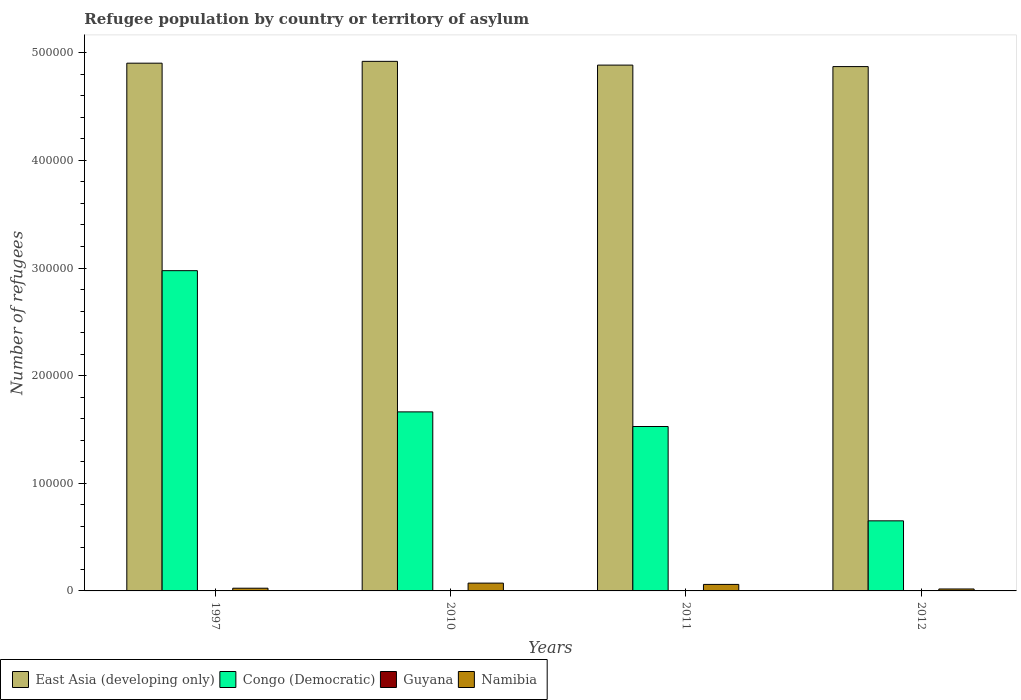How many groups of bars are there?
Offer a very short reply. 4. Are the number of bars per tick equal to the number of legend labels?
Your answer should be compact. Yes. Are the number of bars on each tick of the X-axis equal?
Offer a very short reply. Yes. What is the number of refugees in East Asia (developing only) in 2012?
Keep it short and to the point. 4.87e+05. Across all years, what is the minimum number of refugees in Congo (Democratic)?
Give a very brief answer. 6.51e+04. In which year was the number of refugees in Congo (Democratic) minimum?
Your answer should be very brief. 2012. What is the total number of refugees in Namibia in the graph?
Give a very brief answer. 1.76e+04. What is the difference between the number of refugees in East Asia (developing only) in 1997 and that in 2010?
Provide a succinct answer. -1701. What is the difference between the number of refugees in Guyana in 2010 and the number of refugees in East Asia (developing only) in 2012?
Give a very brief answer. -4.87e+05. What is the average number of refugees in Namibia per year?
Your answer should be compact. 4405. In the year 2011, what is the difference between the number of refugees in Guyana and number of refugees in Namibia?
Keep it short and to the point. -6042. In how many years, is the number of refugees in East Asia (developing only) greater than 120000?
Your response must be concise. 4. What is the ratio of the number of refugees in Namibia in 1997 to that in 2012?
Ensure brevity in your answer.  1.39. Is the number of refugees in Congo (Democratic) in 2011 less than that in 2012?
Your answer should be very brief. No. Is the difference between the number of refugees in Guyana in 1997 and 2012 greater than the difference between the number of refugees in Namibia in 1997 and 2012?
Make the answer very short. No. What is the difference between the highest and the second highest number of refugees in East Asia (developing only)?
Keep it short and to the point. 1701. In how many years, is the number of refugees in East Asia (developing only) greater than the average number of refugees in East Asia (developing only) taken over all years?
Provide a succinct answer. 2. Is the sum of the number of refugees in Guyana in 2010 and 2011 greater than the maximum number of refugees in East Asia (developing only) across all years?
Keep it short and to the point. No. Is it the case that in every year, the sum of the number of refugees in East Asia (developing only) and number of refugees in Congo (Democratic) is greater than the sum of number of refugees in Namibia and number of refugees in Guyana?
Your answer should be very brief. Yes. What does the 4th bar from the left in 2012 represents?
Provide a succinct answer. Namibia. What does the 3rd bar from the right in 2012 represents?
Your response must be concise. Congo (Democratic). Is it the case that in every year, the sum of the number of refugees in Congo (Democratic) and number of refugees in Namibia is greater than the number of refugees in Guyana?
Provide a short and direct response. Yes. How many bars are there?
Provide a short and direct response. 16. How many years are there in the graph?
Your answer should be very brief. 4. What is the difference between two consecutive major ticks on the Y-axis?
Offer a very short reply. 1.00e+05. Are the values on the major ticks of Y-axis written in scientific E-notation?
Your answer should be compact. No. Where does the legend appear in the graph?
Your answer should be very brief. Bottom left. What is the title of the graph?
Provide a succinct answer. Refugee population by country or territory of asylum. Does "World" appear as one of the legend labels in the graph?
Keep it short and to the point. No. What is the label or title of the Y-axis?
Offer a very short reply. Number of refugees. What is the Number of refugees in East Asia (developing only) in 1997?
Provide a succinct answer. 4.90e+05. What is the Number of refugees of Congo (Democratic) in 1997?
Your answer should be very brief. 2.98e+05. What is the Number of refugees of Namibia in 1997?
Keep it short and to the point. 2511. What is the Number of refugees in East Asia (developing only) in 2010?
Provide a succinct answer. 4.92e+05. What is the Number of refugees of Congo (Democratic) in 2010?
Provide a short and direct response. 1.66e+05. What is the Number of refugees in Guyana in 2010?
Offer a terse response. 7. What is the Number of refugees of Namibia in 2010?
Make the answer very short. 7254. What is the Number of refugees in East Asia (developing only) in 2011?
Keep it short and to the point. 4.89e+05. What is the Number of refugees in Congo (Democratic) in 2011?
Make the answer very short. 1.53e+05. What is the Number of refugees of Guyana in 2011?
Ensure brevity in your answer.  7. What is the Number of refugees of Namibia in 2011?
Provide a succinct answer. 6049. What is the Number of refugees of East Asia (developing only) in 2012?
Your answer should be compact. 4.87e+05. What is the Number of refugees of Congo (Democratic) in 2012?
Make the answer very short. 6.51e+04. What is the Number of refugees of Namibia in 2012?
Your response must be concise. 1806. Across all years, what is the maximum Number of refugees of East Asia (developing only)?
Make the answer very short. 4.92e+05. Across all years, what is the maximum Number of refugees of Congo (Democratic)?
Your response must be concise. 2.98e+05. Across all years, what is the maximum Number of refugees in Guyana?
Provide a short and direct response. 7. Across all years, what is the maximum Number of refugees of Namibia?
Your answer should be very brief. 7254. Across all years, what is the minimum Number of refugees in East Asia (developing only)?
Offer a very short reply. 4.87e+05. Across all years, what is the minimum Number of refugees in Congo (Democratic)?
Offer a very short reply. 6.51e+04. Across all years, what is the minimum Number of refugees in Guyana?
Ensure brevity in your answer.  1. Across all years, what is the minimum Number of refugees in Namibia?
Your answer should be very brief. 1806. What is the total Number of refugees in East Asia (developing only) in the graph?
Your response must be concise. 1.96e+06. What is the total Number of refugees in Congo (Democratic) in the graph?
Ensure brevity in your answer.  6.82e+05. What is the total Number of refugees of Namibia in the graph?
Ensure brevity in your answer.  1.76e+04. What is the difference between the Number of refugees of East Asia (developing only) in 1997 and that in 2010?
Give a very brief answer. -1701. What is the difference between the Number of refugees of Congo (Democratic) in 1997 and that in 2010?
Offer a terse response. 1.31e+05. What is the difference between the Number of refugees of Guyana in 1997 and that in 2010?
Your response must be concise. -6. What is the difference between the Number of refugees in Namibia in 1997 and that in 2010?
Keep it short and to the point. -4743. What is the difference between the Number of refugees in East Asia (developing only) in 1997 and that in 2011?
Ensure brevity in your answer.  1779. What is the difference between the Number of refugees of Congo (Democratic) in 1997 and that in 2011?
Make the answer very short. 1.45e+05. What is the difference between the Number of refugees of Guyana in 1997 and that in 2011?
Provide a succinct answer. -6. What is the difference between the Number of refugees of Namibia in 1997 and that in 2011?
Give a very brief answer. -3538. What is the difference between the Number of refugees in East Asia (developing only) in 1997 and that in 2012?
Offer a terse response. 3166. What is the difference between the Number of refugees in Congo (Democratic) in 1997 and that in 2012?
Ensure brevity in your answer.  2.32e+05. What is the difference between the Number of refugees of Namibia in 1997 and that in 2012?
Keep it short and to the point. 705. What is the difference between the Number of refugees of East Asia (developing only) in 2010 and that in 2011?
Offer a very short reply. 3480. What is the difference between the Number of refugees in Congo (Democratic) in 2010 and that in 2011?
Provide a short and direct response. 1.36e+04. What is the difference between the Number of refugees in Namibia in 2010 and that in 2011?
Offer a terse response. 1205. What is the difference between the Number of refugees of East Asia (developing only) in 2010 and that in 2012?
Give a very brief answer. 4867. What is the difference between the Number of refugees of Congo (Democratic) in 2010 and that in 2012?
Your answer should be compact. 1.01e+05. What is the difference between the Number of refugees of Guyana in 2010 and that in 2012?
Offer a very short reply. 0. What is the difference between the Number of refugees in Namibia in 2010 and that in 2012?
Provide a succinct answer. 5448. What is the difference between the Number of refugees of East Asia (developing only) in 2011 and that in 2012?
Your response must be concise. 1387. What is the difference between the Number of refugees in Congo (Democratic) in 2011 and that in 2012?
Ensure brevity in your answer.  8.76e+04. What is the difference between the Number of refugees of Namibia in 2011 and that in 2012?
Give a very brief answer. 4243. What is the difference between the Number of refugees in East Asia (developing only) in 1997 and the Number of refugees in Congo (Democratic) in 2010?
Ensure brevity in your answer.  3.24e+05. What is the difference between the Number of refugees in East Asia (developing only) in 1997 and the Number of refugees in Guyana in 2010?
Provide a succinct answer. 4.90e+05. What is the difference between the Number of refugees of East Asia (developing only) in 1997 and the Number of refugees of Namibia in 2010?
Offer a very short reply. 4.83e+05. What is the difference between the Number of refugees of Congo (Democratic) in 1997 and the Number of refugees of Guyana in 2010?
Your answer should be very brief. 2.98e+05. What is the difference between the Number of refugees of Congo (Democratic) in 1997 and the Number of refugees of Namibia in 2010?
Your answer should be very brief. 2.90e+05. What is the difference between the Number of refugees of Guyana in 1997 and the Number of refugees of Namibia in 2010?
Offer a very short reply. -7253. What is the difference between the Number of refugees of East Asia (developing only) in 1997 and the Number of refugees of Congo (Democratic) in 2011?
Your response must be concise. 3.38e+05. What is the difference between the Number of refugees in East Asia (developing only) in 1997 and the Number of refugees in Guyana in 2011?
Your answer should be very brief. 4.90e+05. What is the difference between the Number of refugees of East Asia (developing only) in 1997 and the Number of refugees of Namibia in 2011?
Offer a terse response. 4.84e+05. What is the difference between the Number of refugees of Congo (Democratic) in 1997 and the Number of refugees of Guyana in 2011?
Your answer should be compact. 2.98e+05. What is the difference between the Number of refugees in Congo (Democratic) in 1997 and the Number of refugees in Namibia in 2011?
Your answer should be compact. 2.91e+05. What is the difference between the Number of refugees of Guyana in 1997 and the Number of refugees of Namibia in 2011?
Keep it short and to the point. -6048. What is the difference between the Number of refugees in East Asia (developing only) in 1997 and the Number of refugees in Congo (Democratic) in 2012?
Provide a short and direct response. 4.25e+05. What is the difference between the Number of refugees of East Asia (developing only) in 1997 and the Number of refugees of Guyana in 2012?
Give a very brief answer. 4.90e+05. What is the difference between the Number of refugees of East Asia (developing only) in 1997 and the Number of refugees of Namibia in 2012?
Make the answer very short. 4.88e+05. What is the difference between the Number of refugees in Congo (Democratic) in 1997 and the Number of refugees in Guyana in 2012?
Ensure brevity in your answer.  2.98e+05. What is the difference between the Number of refugees of Congo (Democratic) in 1997 and the Number of refugees of Namibia in 2012?
Offer a very short reply. 2.96e+05. What is the difference between the Number of refugees of Guyana in 1997 and the Number of refugees of Namibia in 2012?
Offer a very short reply. -1805. What is the difference between the Number of refugees in East Asia (developing only) in 2010 and the Number of refugees in Congo (Democratic) in 2011?
Your answer should be very brief. 3.39e+05. What is the difference between the Number of refugees in East Asia (developing only) in 2010 and the Number of refugees in Guyana in 2011?
Your answer should be very brief. 4.92e+05. What is the difference between the Number of refugees in East Asia (developing only) in 2010 and the Number of refugees in Namibia in 2011?
Provide a short and direct response. 4.86e+05. What is the difference between the Number of refugees of Congo (Democratic) in 2010 and the Number of refugees of Guyana in 2011?
Give a very brief answer. 1.66e+05. What is the difference between the Number of refugees in Congo (Democratic) in 2010 and the Number of refugees in Namibia in 2011?
Your answer should be compact. 1.60e+05. What is the difference between the Number of refugees of Guyana in 2010 and the Number of refugees of Namibia in 2011?
Keep it short and to the point. -6042. What is the difference between the Number of refugees of East Asia (developing only) in 2010 and the Number of refugees of Congo (Democratic) in 2012?
Offer a very short reply. 4.27e+05. What is the difference between the Number of refugees of East Asia (developing only) in 2010 and the Number of refugees of Guyana in 2012?
Give a very brief answer. 4.92e+05. What is the difference between the Number of refugees of East Asia (developing only) in 2010 and the Number of refugees of Namibia in 2012?
Provide a short and direct response. 4.90e+05. What is the difference between the Number of refugees in Congo (Democratic) in 2010 and the Number of refugees in Guyana in 2012?
Offer a terse response. 1.66e+05. What is the difference between the Number of refugees of Congo (Democratic) in 2010 and the Number of refugees of Namibia in 2012?
Make the answer very short. 1.65e+05. What is the difference between the Number of refugees in Guyana in 2010 and the Number of refugees in Namibia in 2012?
Your response must be concise. -1799. What is the difference between the Number of refugees in East Asia (developing only) in 2011 and the Number of refugees in Congo (Democratic) in 2012?
Ensure brevity in your answer.  4.23e+05. What is the difference between the Number of refugees in East Asia (developing only) in 2011 and the Number of refugees in Guyana in 2012?
Ensure brevity in your answer.  4.89e+05. What is the difference between the Number of refugees in East Asia (developing only) in 2011 and the Number of refugees in Namibia in 2012?
Offer a terse response. 4.87e+05. What is the difference between the Number of refugees of Congo (Democratic) in 2011 and the Number of refugees of Guyana in 2012?
Offer a terse response. 1.53e+05. What is the difference between the Number of refugees of Congo (Democratic) in 2011 and the Number of refugees of Namibia in 2012?
Offer a very short reply. 1.51e+05. What is the difference between the Number of refugees of Guyana in 2011 and the Number of refugees of Namibia in 2012?
Give a very brief answer. -1799. What is the average Number of refugees in East Asia (developing only) per year?
Keep it short and to the point. 4.89e+05. What is the average Number of refugees of Congo (Democratic) per year?
Keep it short and to the point. 1.70e+05. What is the average Number of refugees in Guyana per year?
Make the answer very short. 5.5. What is the average Number of refugees of Namibia per year?
Your response must be concise. 4405. In the year 1997, what is the difference between the Number of refugees in East Asia (developing only) and Number of refugees in Congo (Democratic)?
Your answer should be very brief. 1.93e+05. In the year 1997, what is the difference between the Number of refugees of East Asia (developing only) and Number of refugees of Guyana?
Keep it short and to the point. 4.90e+05. In the year 1997, what is the difference between the Number of refugees of East Asia (developing only) and Number of refugees of Namibia?
Offer a very short reply. 4.88e+05. In the year 1997, what is the difference between the Number of refugees in Congo (Democratic) and Number of refugees in Guyana?
Offer a very short reply. 2.98e+05. In the year 1997, what is the difference between the Number of refugees in Congo (Democratic) and Number of refugees in Namibia?
Your answer should be very brief. 2.95e+05. In the year 1997, what is the difference between the Number of refugees in Guyana and Number of refugees in Namibia?
Make the answer very short. -2510. In the year 2010, what is the difference between the Number of refugees in East Asia (developing only) and Number of refugees in Congo (Democratic)?
Provide a short and direct response. 3.26e+05. In the year 2010, what is the difference between the Number of refugees of East Asia (developing only) and Number of refugees of Guyana?
Ensure brevity in your answer.  4.92e+05. In the year 2010, what is the difference between the Number of refugees of East Asia (developing only) and Number of refugees of Namibia?
Give a very brief answer. 4.85e+05. In the year 2010, what is the difference between the Number of refugees in Congo (Democratic) and Number of refugees in Guyana?
Keep it short and to the point. 1.66e+05. In the year 2010, what is the difference between the Number of refugees in Congo (Democratic) and Number of refugees in Namibia?
Offer a very short reply. 1.59e+05. In the year 2010, what is the difference between the Number of refugees of Guyana and Number of refugees of Namibia?
Keep it short and to the point. -7247. In the year 2011, what is the difference between the Number of refugees of East Asia (developing only) and Number of refugees of Congo (Democratic)?
Ensure brevity in your answer.  3.36e+05. In the year 2011, what is the difference between the Number of refugees of East Asia (developing only) and Number of refugees of Guyana?
Offer a terse response. 4.89e+05. In the year 2011, what is the difference between the Number of refugees in East Asia (developing only) and Number of refugees in Namibia?
Give a very brief answer. 4.82e+05. In the year 2011, what is the difference between the Number of refugees of Congo (Democratic) and Number of refugees of Guyana?
Make the answer very short. 1.53e+05. In the year 2011, what is the difference between the Number of refugees in Congo (Democratic) and Number of refugees in Namibia?
Ensure brevity in your answer.  1.47e+05. In the year 2011, what is the difference between the Number of refugees of Guyana and Number of refugees of Namibia?
Ensure brevity in your answer.  -6042. In the year 2012, what is the difference between the Number of refugees in East Asia (developing only) and Number of refugees in Congo (Democratic)?
Give a very brief answer. 4.22e+05. In the year 2012, what is the difference between the Number of refugees of East Asia (developing only) and Number of refugees of Guyana?
Offer a terse response. 4.87e+05. In the year 2012, what is the difference between the Number of refugees in East Asia (developing only) and Number of refugees in Namibia?
Keep it short and to the point. 4.85e+05. In the year 2012, what is the difference between the Number of refugees in Congo (Democratic) and Number of refugees in Guyana?
Your answer should be compact. 6.51e+04. In the year 2012, what is the difference between the Number of refugees in Congo (Democratic) and Number of refugees in Namibia?
Keep it short and to the point. 6.33e+04. In the year 2012, what is the difference between the Number of refugees in Guyana and Number of refugees in Namibia?
Provide a succinct answer. -1799. What is the ratio of the Number of refugees in East Asia (developing only) in 1997 to that in 2010?
Offer a very short reply. 1. What is the ratio of the Number of refugees of Congo (Democratic) in 1997 to that in 2010?
Make the answer very short. 1.79. What is the ratio of the Number of refugees of Guyana in 1997 to that in 2010?
Make the answer very short. 0.14. What is the ratio of the Number of refugees in Namibia in 1997 to that in 2010?
Your response must be concise. 0.35. What is the ratio of the Number of refugees of East Asia (developing only) in 1997 to that in 2011?
Offer a terse response. 1. What is the ratio of the Number of refugees of Congo (Democratic) in 1997 to that in 2011?
Offer a very short reply. 1.95. What is the ratio of the Number of refugees of Guyana in 1997 to that in 2011?
Offer a terse response. 0.14. What is the ratio of the Number of refugees of Namibia in 1997 to that in 2011?
Offer a terse response. 0.42. What is the ratio of the Number of refugees in Congo (Democratic) in 1997 to that in 2012?
Provide a succinct answer. 4.57. What is the ratio of the Number of refugees of Guyana in 1997 to that in 2012?
Your answer should be compact. 0.14. What is the ratio of the Number of refugees of Namibia in 1997 to that in 2012?
Offer a terse response. 1.39. What is the ratio of the Number of refugees in East Asia (developing only) in 2010 to that in 2011?
Provide a short and direct response. 1.01. What is the ratio of the Number of refugees in Congo (Democratic) in 2010 to that in 2011?
Your answer should be very brief. 1.09. What is the ratio of the Number of refugees in Guyana in 2010 to that in 2011?
Ensure brevity in your answer.  1. What is the ratio of the Number of refugees of Namibia in 2010 to that in 2011?
Your response must be concise. 1.2. What is the ratio of the Number of refugees in Congo (Democratic) in 2010 to that in 2012?
Your answer should be very brief. 2.55. What is the ratio of the Number of refugees in Guyana in 2010 to that in 2012?
Keep it short and to the point. 1. What is the ratio of the Number of refugees in Namibia in 2010 to that in 2012?
Your answer should be compact. 4.02. What is the ratio of the Number of refugees in Congo (Democratic) in 2011 to that in 2012?
Provide a short and direct response. 2.35. What is the ratio of the Number of refugees of Namibia in 2011 to that in 2012?
Your response must be concise. 3.35. What is the difference between the highest and the second highest Number of refugees in East Asia (developing only)?
Make the answer very short. 1701. What is the difference between the highest and the second highest Number of refugees of Congo (Democratic)?
Ensure brevity in your answer.  1.31e+05. What is the difference between the highest and the second highest Number of refugees in Guyana?
Your response must be concise. 0. What is the difference between the highest and the second highest Number of refugees of Namibia?
Your answer should be very brief. 1205. What is the difference between the highest and the lowest Number of refugees of East Asia (developing only)?
Give a very brief answer. 4867. What is the difference between the highest and the lowest Number of refugees of Congo (Democratic)?
Make the answer very short. 2.32e+05. What is the difference between the highest and the lowest Number of refugees of Namibia?
Your answer should be compact. 5448. 